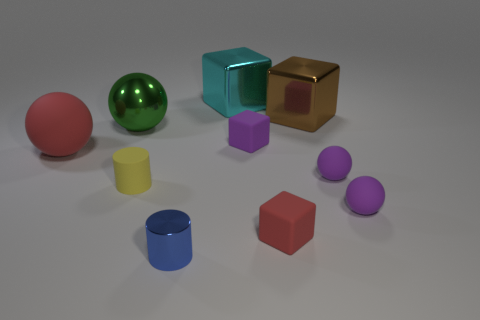Subtract all red cylinders. Subtract all green balls. How many cylinders are left? 2 Subtract all blocks. How many objects are left? 6 Add 5 big matte balls. How many big matte balls are left? 6 Add 1 cyan blocks. How many cyan blocks exist? 2 Subtract 1 red spheres. How many objects are left? 9 Subtract all big red matte spheres. Subtract all small red matte blocks. How many objects are left? 8 